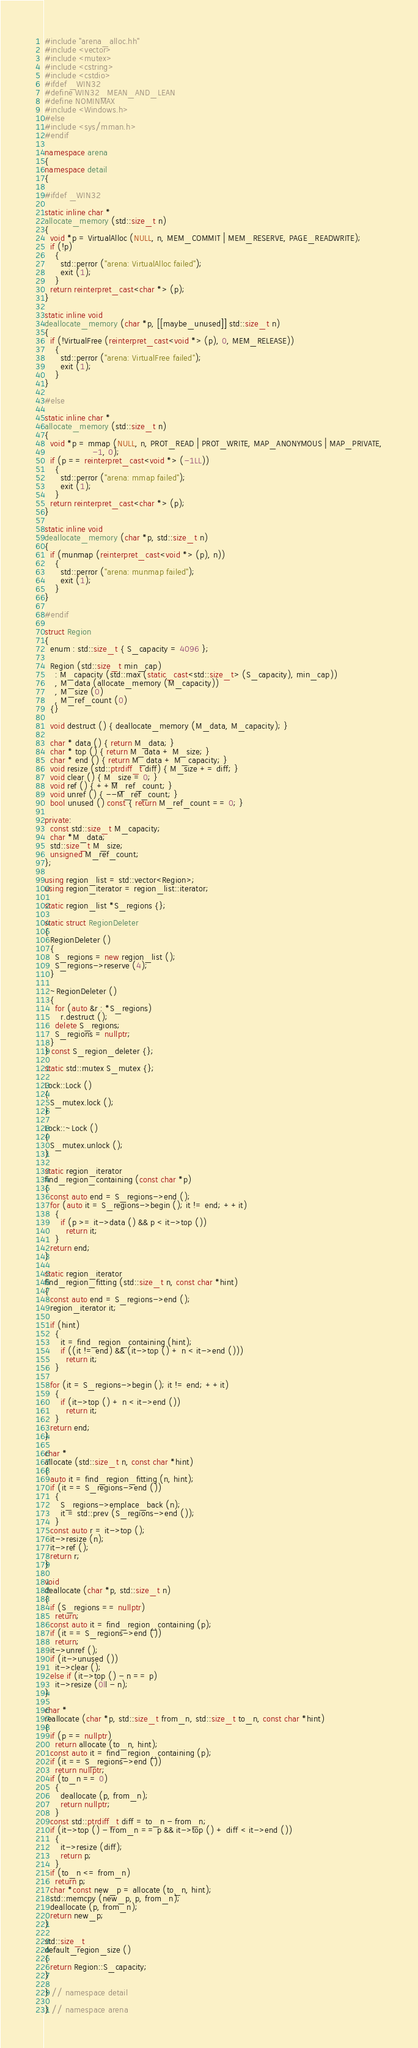<code> <loc_0><loc_0><loc_500><loc_500><_C++_>#include "arena_alloc.hh"
#include <vector>
#include <mutex>
#include <cstring>
#include <cstdio>
#ifdef _WIN32
#define WIN32_MEAN_AND_LEAN
#define NOMINMAX
#include <Windows.h>
#else
#include <sys/mman.h>
#endif

namespace arena
{
namespace detail
{

#ifdef _WIN32

static inline char *
allocate_memory (std::size_t n)
{
  void *p = VirtualAlloc (NULL, n, MEM_COMMIT | MEM_RESERVE, PAGE_READWRITE);
  if (!p)
    {
      std::perror ("arena: VirtualAlloc failed");
      exit (1);
    }
  return reinterpret_cast<char *> (p);
}

static inline void
deallocate_memory (char *p, [[maybe_unused]] std::size_t n)
{
  if (!VirtualFree (reinterpret_cast<void *> (p), 0, MEM_RELEASE))
    {
      std::perror ("arena: VirtualFree failed");
      exit (1);
    }
}

#else

static inline char *
allocate_memory (std::size_t n)
{
  void *p = mmap (NULL, n, PROT_READ | PROT_WRITE, MAP_ANONYMOUS | MAP_PRIVATE,
                  -1, 0);
  if (p == reinterpret_cast<void *> (-1LL))
    {
      std::perror ("arena: mmap failed");
      exit (1);
    }
  return reinterpret_cast<char *> (p);
}

static inline void
deallocate_memory (char *p, std::size_t n)
{
  if (munmap (reinterpret_cast<void *> (p), n))
    {
      std::perror ("arena: munmap failed");
      exit (1);
    }
}

#endif

struct Region
{
  enum : std::size_t { S_capacity = 4096 };

  Region (std::size_t min_cap)
    : M_capacity (std::max (static_cast<std::size_t> (S_capacity), min_cap))
    , M_data (allocate_memory (M_capacity))
    , M_size (0)
    , M_ref_count (0)
  {}

  void destruct () { deallocate_memory (M_data, M_capacity); }

  char * data () { return M_data; }
  char * top () { return M_data + M_size; }
  char * end () { return M_data + M_capacity; }
  void resize (std::ptrdiff_t diff) { M_size += diff; }
  void clear () { M_size = 0; }
  void ref () { ++M_ref_count; }
  void unref () { --M_ref_count; }
  bool unused () const { return M_ref_count == 0; }

private:
  const std::size_t M_capacity;
  char *M_data;
  std::size_t M_size;
  unsigned M_ref_count;
};

using region_list = std::vector<Region>;
using region_iterator = region_list::iterator;

static region_list *S_regions {};

static struct RegionDeleter
{
  RegionDeleter ()
  {
    S_regions = new region_list ();
    S_regions->reserve (4);
  }

  ~RegionDeleter ()
  {
    for (auto &r : *S_regions)
      r.destruct ();
    delete S_regions;
    S_regions = nullptr;
  }
} const S_region_deleter {};

static std::mutex S_mutex {};

Lock::Lock ()
{
  S_mutex.lock ();
}

Lock::~Lock ()
{
  S_mutex.unlock ();
}

static region_iterator
find_region_containing (const char *p)
{
  const auto end = S_regions->end ();
  for (auto it = S_regions->begin (); it != end; ++it)
    {
      if (p >= it->data () && p < it->top ())
        return it;
    }
  return end;
}

static region_iterator
find_region_fitting (std::size_t n, const char *hint)
{
  const auto end = S_regions->end ();
  region_iterator it;

  if (hint)
    {
      it = find_region_containing (hint);
      if ((it != end) && (it->top () + n < it->end ()))
        return it;
    }

  for (it = S_regions->begin (); it != end; ++it)
    {
      if (it->top () + n < it->end ())
        return it;
    }
  return end;
}

char *
allocate (std::size_t n, const char *hint)
{
  auto it = find_region_fitting (n, hint);
  if (it == S_regions->end ())
    {
      S_regions->emplace_back (n);
      it = std::prev (S_regions->end ());
    }
  const auto r = it->top ();
  it->resize (n);
  it->ref ();
  return r;
}

void
deallocate (char *p, std::size_t n)
{
  if (S_regions == nullptr)
    return;
  const auto it = find_region_containing (p);
  if (it == S_regions->end ())
    return;
  it->unref ();
  if (it->unused ())
    it->clear ();
  else if (it->top () - n == p)
    it->resize (0ll - n);
}

char *
reallocate (char *p, std::size_t from_n, std::size_t to_n, const char *hint)
{
  if (p == nullptr)
    return allocate (to_n, hint);
  const auto it = find_region_containing (p);
  if (it == S_regions->end ())
    return nullptr;
  if (to_n == 0)
    {
      deallocate (p, from_n);
      return nullptr;
    }
  const std::ptrdiff_t diff = to_n - from_n;
  if (it->top () - from_n == p && it->top () + diff < it->end ())
    {
      it->resize (diff);
      return p;
    }
  if (to_n <= from_n)
    return p;
  char *const new_p = allocate (to_n, hint);
  std::memcpy (new_p, p, from_n);
  deallocate (p, from_n);
  return new_p;
}

std::size_t
default_region_size ()
{
  return Region::S_capacity;
}

} // namespace detail

} // namespace arena
</code> 